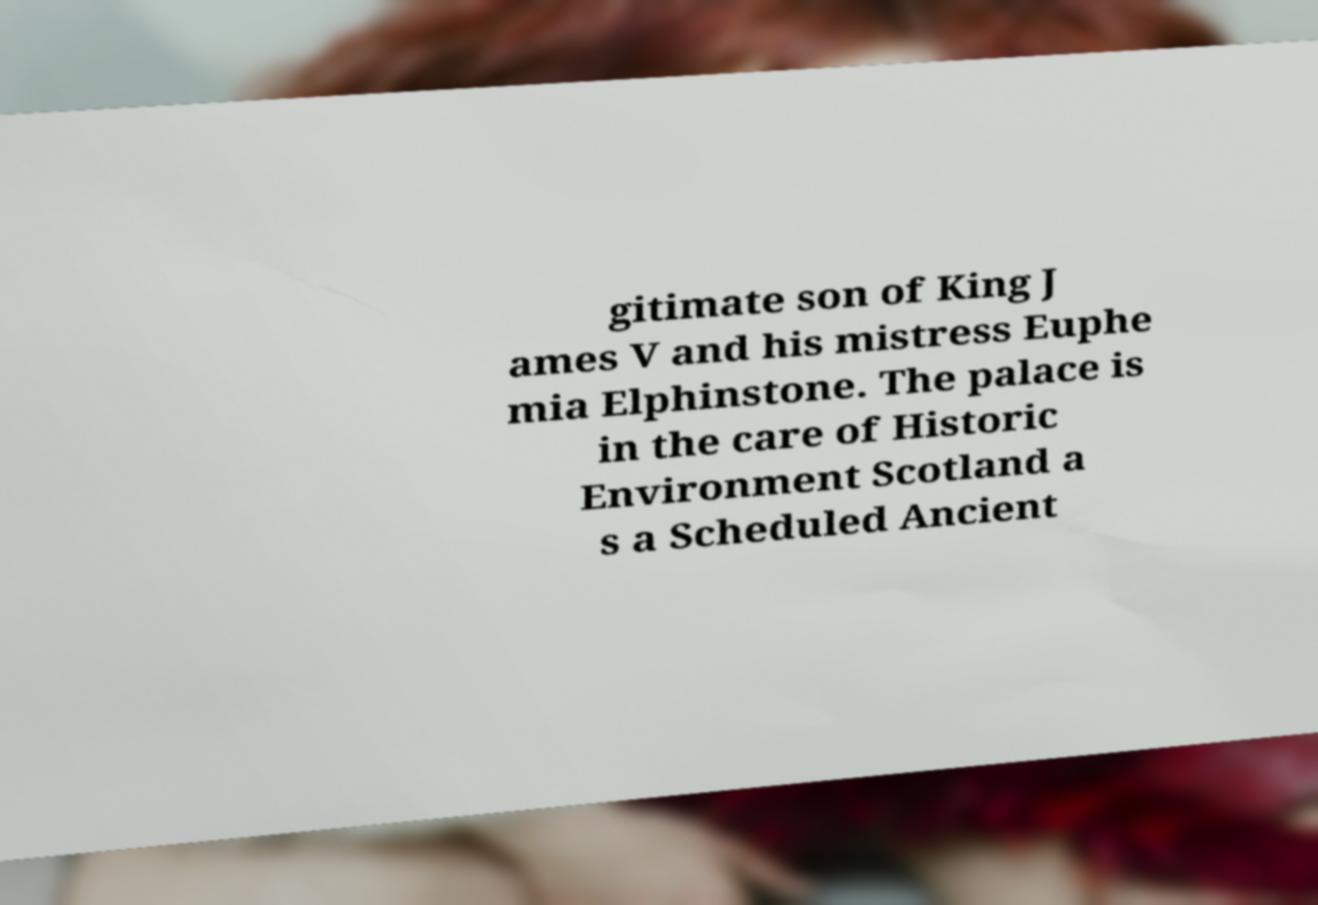Please identify and transcribe the text found in this image. gitimate son of King J ames V and his mistress Euphe mia Elphinstone. The palace is in the care of Historic Environment Scotland a s a Scheduled Ancient 